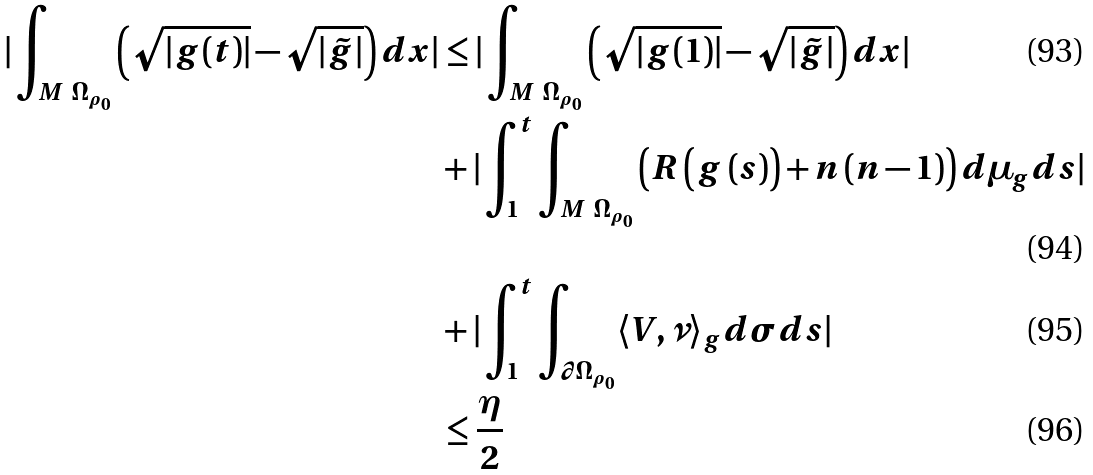Convert formula to latex. <formula><loc_0><loc_0><loc_500><loc_500>| \int _ { M \ \Omega _ { \rho _ { 0 } } } \left ( \sqrt { | g ( t ) | } - \sqrt { | \tilde { g } | } \right ) d x | & \leq | \int _ { M \ \Omega _ { \rho _ { 0 } } } \left ( \sqrt { | g ( 1 ) | } - \sqrt { | \tilde { g } | } \right ) d x | \\ & + | \int ^ { t } _ { 1 } \int _ { M \ \Omega _ { \rho _ { 0 } } } \left ( R \left ( g \left ( s \right ) \right ) + n \left ( n - 1 \right ) \right ) d \mu _ { g } d s | \\ & + | \int ^ { t } _ { 1 } \int _ { \partial \Omega _ { \rho _ { 0 } } } \langle V , \nu \rangle _ { g } d \sigma d s | \\ & \leq \frac { \eta } { 2 }</formula> 